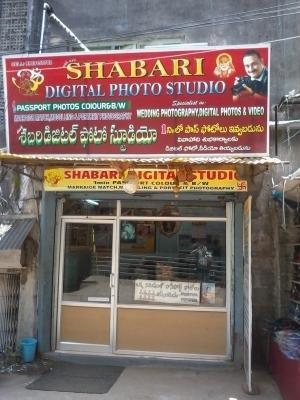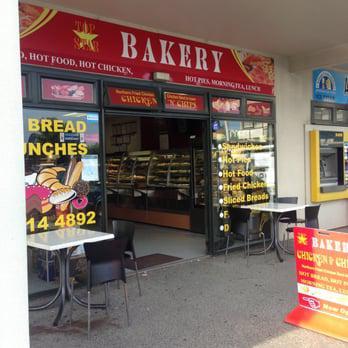The first image is the image on the left, the second image is the image on the right. For the images displayed, is the sentence "An exterior view shows a star shape near lettering above a square opening in the right image." factually correct? Answer yes or no. Yes. The first image is the image on the left, the second image is the image on the right. Considering the images on both sides, is "there is a bakery with a star shape on their sign and black framed windows" valid? Answer yes or no. Yes. 